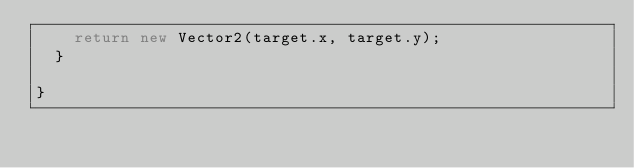<code> <loc_0><loc_0><loc_500><loc_500><_C#_>		return new Vector2(target.x, target.y);
	}
	
}</code> 